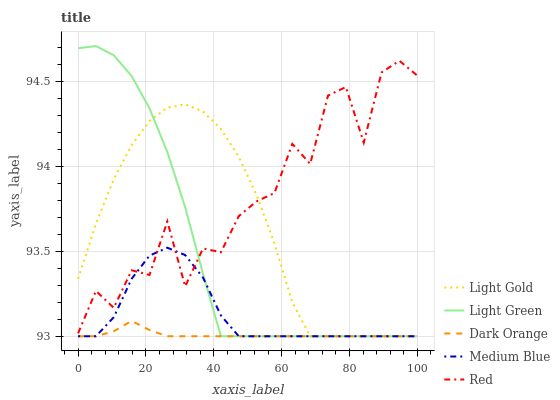Does Dark Orange have the minimum area under the curve?
Answer yes or no. Yes. Does Red have the maximum area under the curve?
Answer yes or no. Yes. Does Light Gold have the minimum area under the curve?
Answer yes or no. No. Does Light Gold have the maximum area under the curve?
Answer yes or no. No. Is Dark Orange the smoothest?
Answer yes or no. Yes. Is Red the roughest?
Answer yes or no. Yes. Is Light Gold the smoothest?
Answer yes or no. No. Is Light Gold the roughest?
Answer yes or no. No. Does Dark Orange have the lowest value?
Answer yes or no. Yes. Does Red have the lowest value?
Answer yes or no. No. Does Light Green have the highest value?
Answer yes or no. Yes. Does Red have the highest value?
Answer yes or no. No. Is Dark Orange less than Red?
Answer yes or no. Yes. Is Red greater than Dark Orange?
Answer yes or no. Yes. Does Red intersect Medium Blue?
Answer yes or no. Yes. Is Red less than Medium Blue?
Answer yes or no. No. Is Red greater than Medium Blue?
Answer yes or no. No. Does Dark Orange intersect Red?
Answer yes or no. No. 